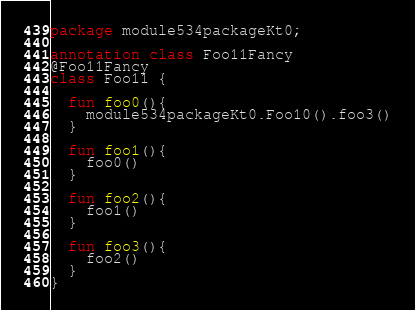Convert code to text. <code><loc_0><loc_0><loc_500><loc_500><_Kotlin_>package module534packageKt0;

annotation class Foo11Fancy
@Foo11Fancy
class Foo11 {

  fun foo0(){
    module534packageKt0.Foo10().foo3()
  }

  fun foo1(){
    foo0()
  }

  fun foo2(){
    foo1()
  }

  fun foo3(){
    foo2()
  }
}</code> 